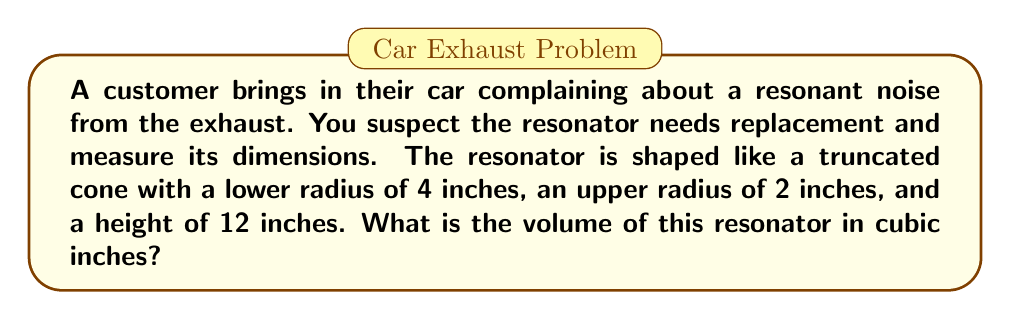Solve this math problem. To find the volume of a truncated cone, we'll use the formula:

$$V = \frac{1}{3}\pi h(R^2 + r^2 + Rr)$$

Where:
$V$ = volume
$h$ = height
$R$ = radius of the larger base
$r$ = radius of the smaller base

Given:
$h = 12$ inches
$R = 4$ inches (lower radius)
$r = 2$ inches (upper radius)

Let's substitute these values into the formula:

$$V = \frac{1}{3}\pi \cdot 12(4^2 + 2^2 + 4 \cdot 2)$$

Simplify:
$$V = 4\pi(16 + 4 + 8)$$
$$V = 4\pi(28)$$
$$V = 112\pi$$

The exact volume is $112\pi$ cubic inches. If we need to approximate:

$$V \approx 112 \cdot 3.14159 \approx 351.86$$ cubic inches

[asy]
import geometry;

size(200);
real r1=2, r2=4, h=12;
pair A=(0,0), B=(r2,0), C=(r1,h), D=(0,h);
draw(A--B--C--D--cycle);
draw(B--(r1,h));
label("4\"",B,S);
label("2\"",C,N);
label("12\"",D,W);
[/asy]
Answer: $112\pi$ cubic inches (or approximately 351.86 cubic inches) 